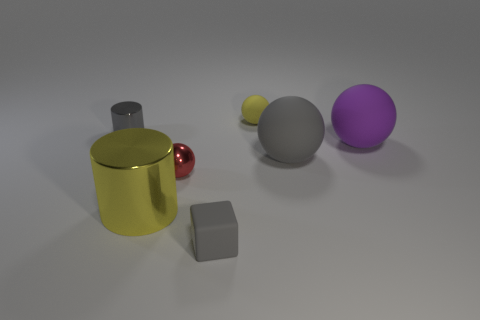Add 1 spheres. How many objects exist? 8 Subtract all gray cylinders. How many cylinders are left? 1 Subtract all gray balls. How many balls are left? 3 Subtract all blocks. How many objects are left? 6 Subtract all gray cylinders. Subtract all cyan spheres. How many cylinders are left? 1 Subtract all gray cylinders. How many brown cubes are left? 0 Subtract all purple spheres. Subtract all big matte spheres. How many objects are left? 4 Add 3 yellow balls. How many yellow balls are left? 4 Add 2 gray cylinders. How many gray cylinders exist? 3 Subtract 0 green cylinders. How many objects are left? 7 